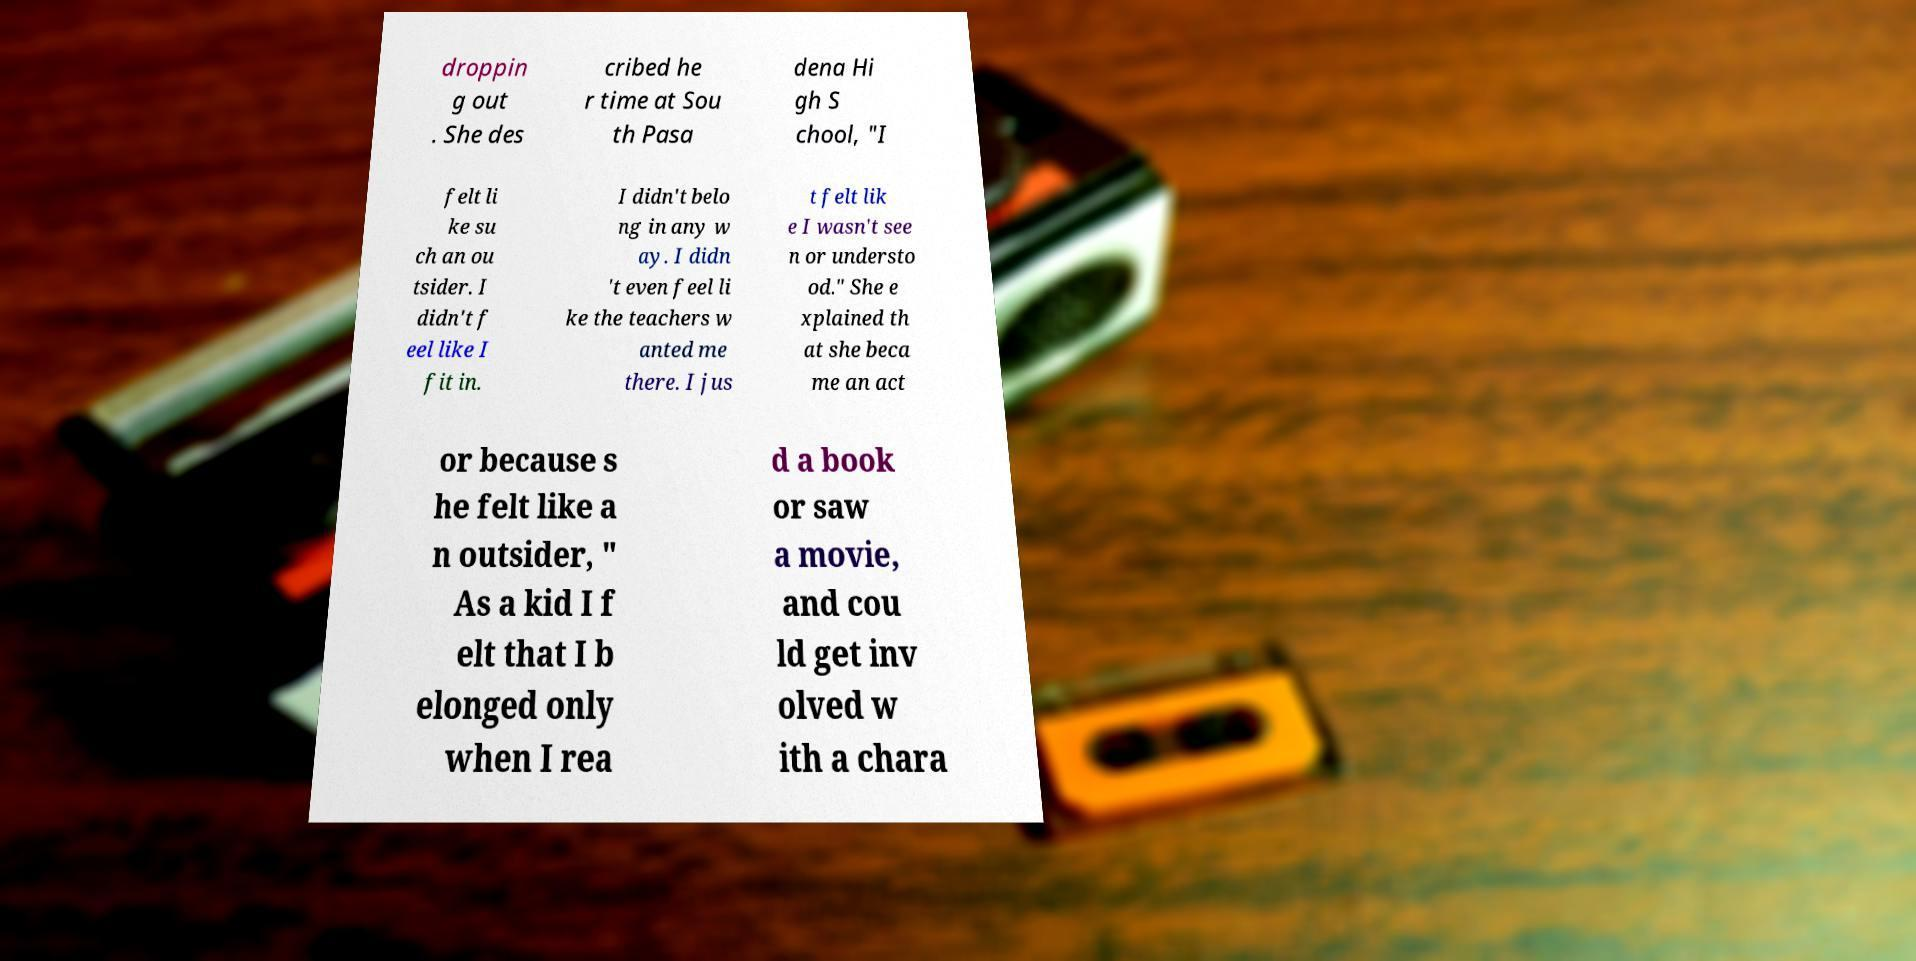Please read and relay the text visible in this image. What does it say? droppin g out . She des cribed he r time at Sou th Pasa dena Hi gh S chool, "I felt li ke su ch an ou tsider. I didn't f eel like I fit in. I didn't belo ng in any w ay. I didn 't even feel li ke the teachers w anted me there. I jus t felt lik e I wasn't see n or understo od." She e xplained th at she beca me an act or because s he felt like a n outsider, " As a kid I f elt that I b elonged only when I rea d a book or saw a movie, and cou ld get inv olved w ith a chara 